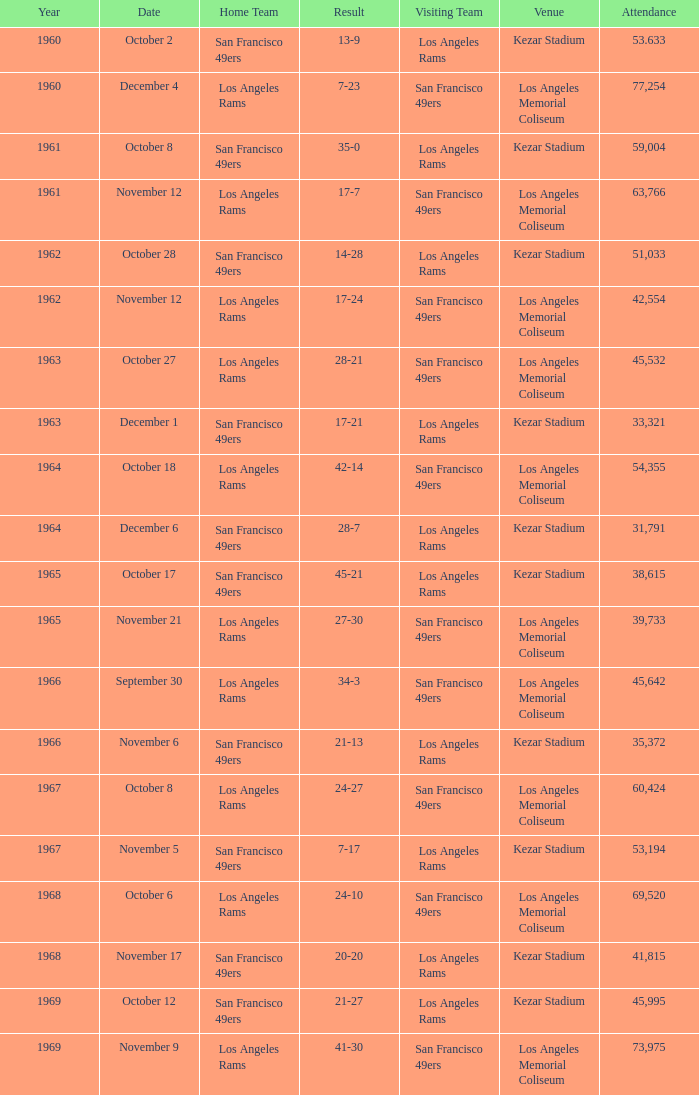Help me parse the entirety of this table. {'header': ['Year', 'Date', 'Home Team', 'Result', 'Visiting Team', 'Venue', 'Attendance'], 'rows': [['1960', 'October 2', 'San Francisco 49ers', '13-9', 'Los Angeles Rams', 'Kezar Stadium', '53.633'], ['1960', 'December 4', 'Los Angeles Rams', '7-23', 'San Francisco 49ers', 'Los Angeles Memorial Coliseum', '77,254'], ['1961', 'October 8', 'San Francisco 49ers', '35-0', 'Los Angeles Rams', 'Kezar Stadium', '59,004'], ['1961', 'November 12', 'Los Angeles Rams', '17-7', 'San Francisco 49ers', 'Los Angeles Memorial Coliseum', '63,766'], ['1962', 'October 28', 'San Francisco 49ers', '14-28', 'Los Angeles Rams', 'Kezar Stadium', '51,033'], ['1962', 'November 12', 'Los Angeles Rams', '17-24', 'San Francisco 49ers', 'Los Angeles Memorial Coliseum', '42,554'], ['1963', 'October 27', 'Los Angeles Rams', '28-21', 'San Francisco 49ers', 'Los Angeles Memorial Coliseum', '45,532'], ['1963', 'December 1', 'San Francisco 49ers', '17-21', 'Los Angeles Rams', 'Kezar Stadium', '33,321'], ['1964', 'October 18', 'Los Angeles Rams', '42-14', 'San Francisco 49ers', 'Los Angeles Memorial Coliseum', '54,355'], ['1964', 'December 6', 'San Francisco 49ers', '28-7', 'Los Angeles Rams', 'Kezar Stadium', '31,791'], ['1965', 'October 17', 'San Francisco 49ers', '45-21', 'Los Angeles Rams', 'Kezar Stadium', '38,615'], ['1965', 'November 21', 'Los Angeles Rams', '27-30', 'San Francisco 49ers', 'Los Angeles Memorial Coliseum', '39,733'], ['1966', 'September 30', 'Los Angeles Rams', '34-3', 'San Francisco 49ers', 'Los Angeles Memorial Coliseum', '45,642'], ['1966', 'November 6', 'San Francisco 49ers', '21-13', 'Los Angeles Rams', 'Kezar Stadium', '35,372'], ['1967', 'October 8', 'Los Angeles Rams', '24-27', 'San Francisco 49ers', 'Los Angeles Memorial Coliseum', '60,424'], ['1967', 'November 5', 'San Francisco 49ers', '7-17', 'Los Angeles Rams', 'Kezar Stadium', '53,194'], ['1968', 'October 6', 'Los Angeles Rams', '24-10', 'San Francisco 49ers', 'Los Angeles Memorial Coliseum', '69,520'], ['1968', 'November 17', 'San Francisco 49ers', '20-20', 'Los Angeles Rams', 'Kezar Stadium', '41,815'], ['1969', 'October 12', 'San Francisco 49ers', '21-27', 'Los Angeles Rams', 'Kezar Stadium', '45,995'], ['1969', 'November 9', 'Los Angeles Rams', '41-30', 'San Francisco 49ers', 'Los Angeles Memorial Coliseum', '73,975']]} When the san francisco 49ers are visiting with an attendance of more than 45,532 on September 30, who was the home team? Los Angeles Rams. 